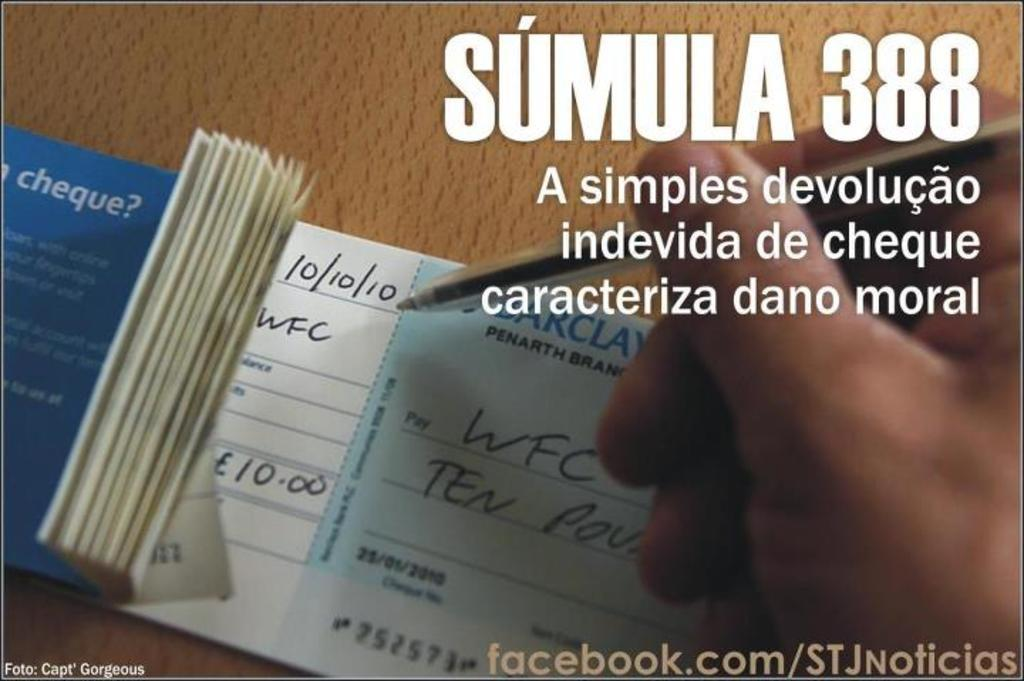What is the main object in the image? There is a cheque book in the image. What is the person in the image doing? A person's hand is holding a pen in the image. Can you describe any writing or text visible in the image? There is text visible in the image. What color is the orange in the image? There is no orange present in the image. What type of ink is being used by the person in the image? The image does not show the type of ink being used, only the person's hand holding a pen. 